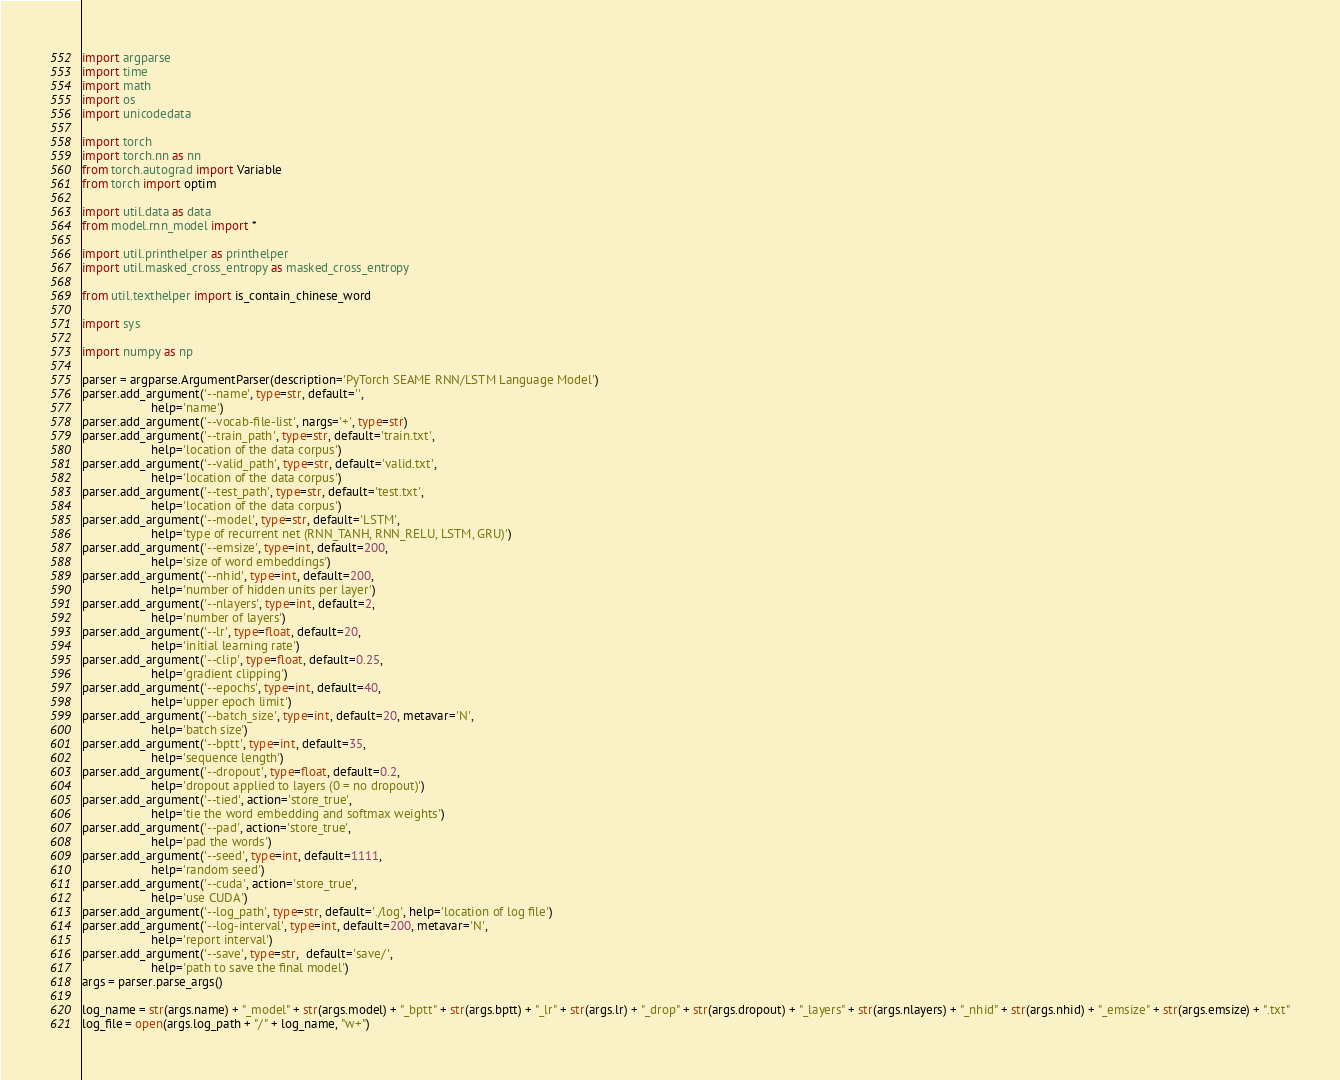<code> <loc_0><loc_0><loc_500><loc_500><_Python_>import argparse
import time
import math
import os
import unicodedata

import torch
import torch.nn as nn
from torch.autograd import Variable
from torch import optim

import util.data as data
from model.rnn_model import *

import util.printhelper as printhelper
import util.masked_cross_entropy as masked_cross_entropy

from util.texthelper import is_contain_chinese_word

import sys

import numpy as np

parser = argparse.ArgumentParser(description='PyTorch SEAME RNN/LSTM Language Model')
parser.add_argument('--name', type=str, default='',
                    help='name')
parser.add_argument('--vocab-file-list', nargs='+', type=str)
parser.add_argument('--train_path', type=str, default='train.txt',
                    help='location of the data corpus')
parser.add_argument('--valid_path', type=str, default='valid.txt',
                    help='location of the data corpus')
parser.add_argument('--test_path', type=str, default='test.txt',
                    help='location of the data corpus')
parser.add_argument('--model', type=str, default='LSTM',
                    help='type of recurrent net (RNN_TANH, RNN_RELU, LSTM, GRU)')
parser.add_argument('--emsize', type=int, default=200,
                    help='size of word embeddings')
parser.add_argument('--nhid', type=int, default=200,
                    help='number of hidden units per layer')
parser.add_argument('--nlayers', type=int, default=2,
                    help='number of layers')
parser.add_argument('--lr', type=float, default=20,
                    help='initial learning rate')
parser.add_argument('--clip', type=float, default=0.25,
                    help='gradient clipping')
parser.add_argument('--epochs', type=int, default=40,
                    help='upper epoch limit')
parser.add_argument('--batch_size', type=int, default=20, metavar='N',
                    help='batch size')
parser.add_argument('--bptt', type=int, default=35,
                    help='sequence length')
parser.add_argument('--dropout', type=float, default=0.2,
                    help='dropout applied to layers (0 = no dropout)')
parser.add_argument('--tied', action='store_true',
                    help='tie the word embedding and softmax weights')
parser.add_argument('--pad', action='store_true',
                    help='pad the words')
parser.add_argument('--seed', type=int, default=1111,
                    help='random seed')
parser.add_argument('--cuda', action='store_true',
                    help='use CUDA')
parser.add_argument('--log_path', type=str, default='./log', help='location of log file')
parser.add_argument('--log-interval', type=int, default=200, metavar='N',
                    help='report interval')
parser.add_argument('--save', type=str,  default='save/',
                    help='path to save the final model')
args = parser.parse_args()

log_name = str(args.name) + "_model" + str(args.model) + "_bptt" + str(args.bptt) + "_lr" + str(args.lr) + "_drop" + str(args.dropout) + "_layers" + str(args.nlayers) + "_nhid" + str(args.nhid) + "_emsize" + str(args.emsize) + ".txt"
log_file = open(args.log_path + "/" + log_name, "w+")
</code> 